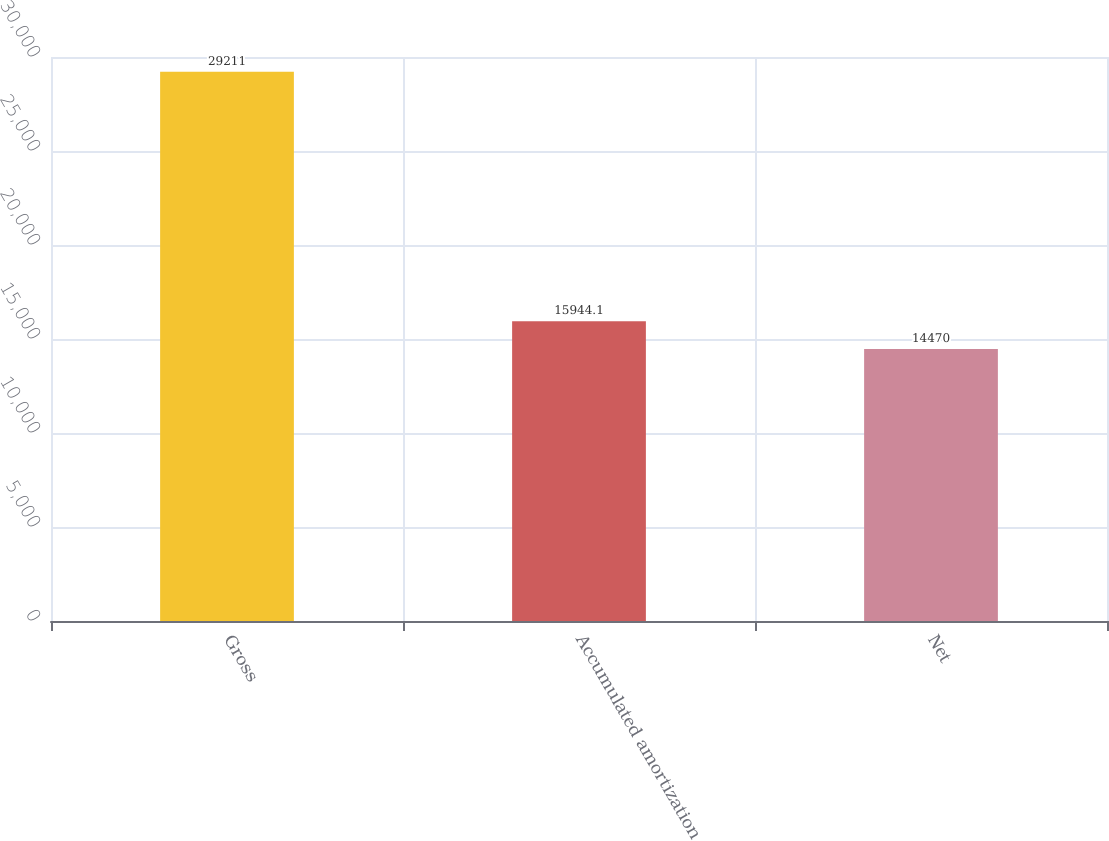<chart> <loc_0><loc_0><loc_500><loc_500><bar_chart><fcel>Gross<fcel>Accumulated amortization<fcel>Net<nl><fcel>29211<fcel>15944.1<fcel>14470<nl></chart> 